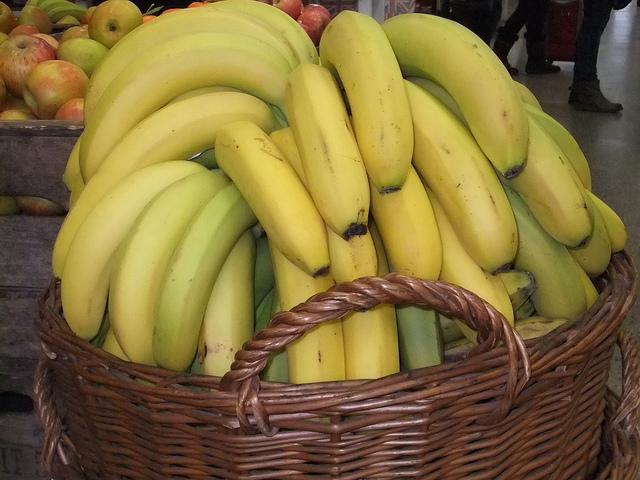What pome fruits are shown here?

Choices:
A) oranges
B) cherries
C) bananas
D) apples apples 